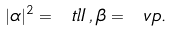Convert formula to latex. <formula><loc_0><loc_0><loc_500><loc_500>| \alpha | ^ { 2 } = \ t l { I } \, , \beta = \ v p .</formula> 